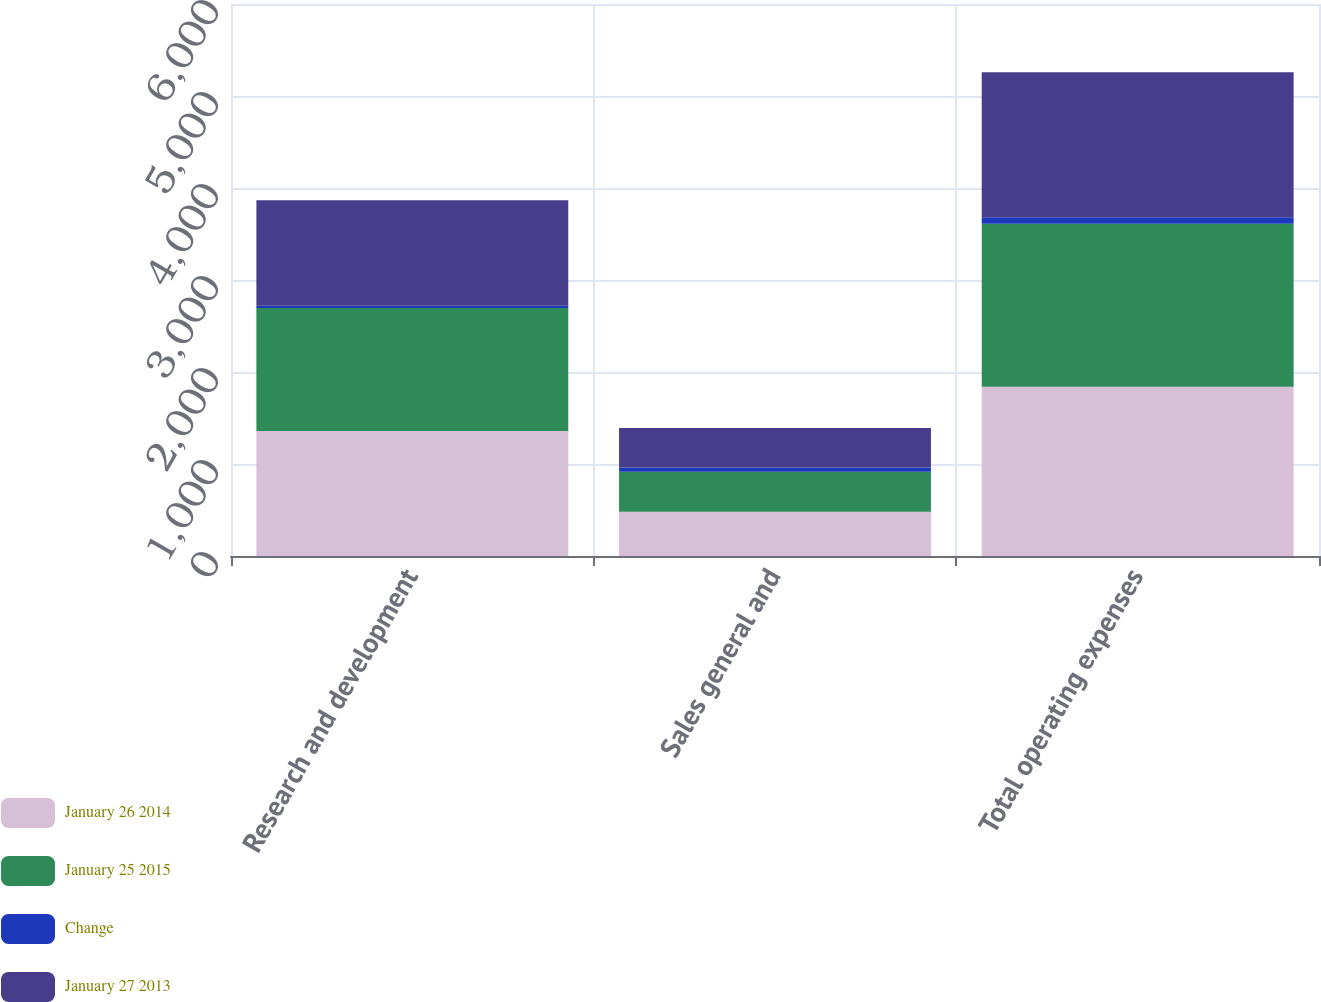<chart> <loc_0><loc_0><loc_500><loc_500><stacked_bar_chart><ecel><fcel>Research and development<fcel>Sales general and<fcel>Total operating expenses<nl><fcel>January 26 2014<fcel>1359.7<fcel>480.8<fcel>1840.5<nl><fcel>January 25 2015<fcel>1335.8<fcel>435.7<fcel>1771.5<nl><fcel>Change<fcel>23.9<fcel>45.1<fcel>69<nl><fcel>January 27 2013<fcel>1147.3<fcel>430.8<fcel>1578.1<nl></chart> 